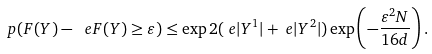<formula> <loc_0><loc_0><loc_500><loc_500>\ p ( F ( Y ) - \ e F ( Y ) \geq \varepsilon ) & \leq \exp 2 ( \ e | Y ^ { 1 } | + \ e | Y ^ { 2 } | ) \exp \left ( - \frac { \varepsilon ^ { 2 } N } { 1 6 d } \right ) .</formula> 